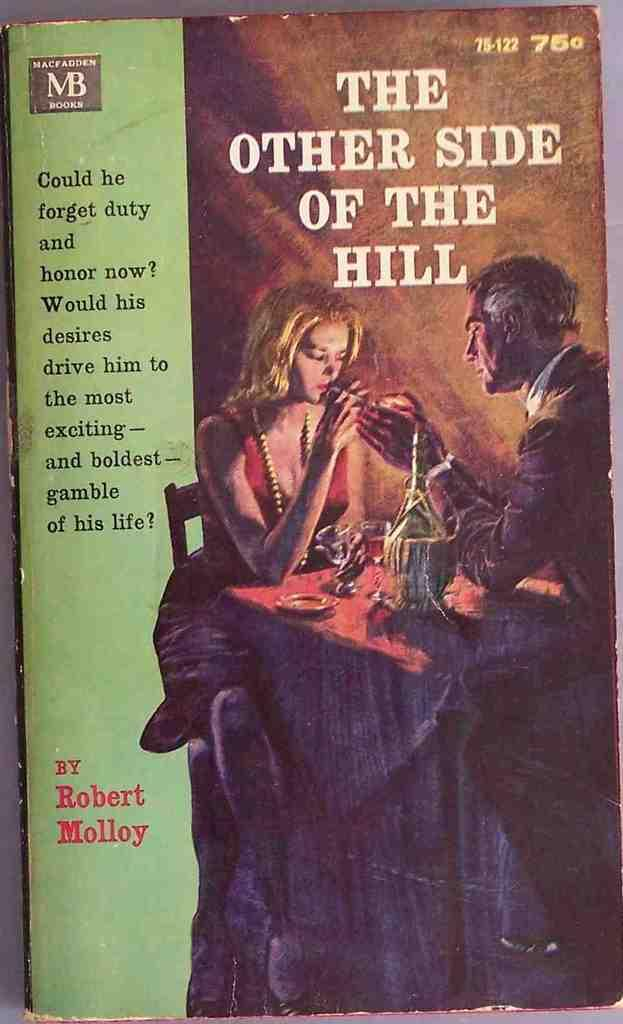<image>
Give a short and clear explanation of the subsequent image. a book called The Other Side of the Hill 